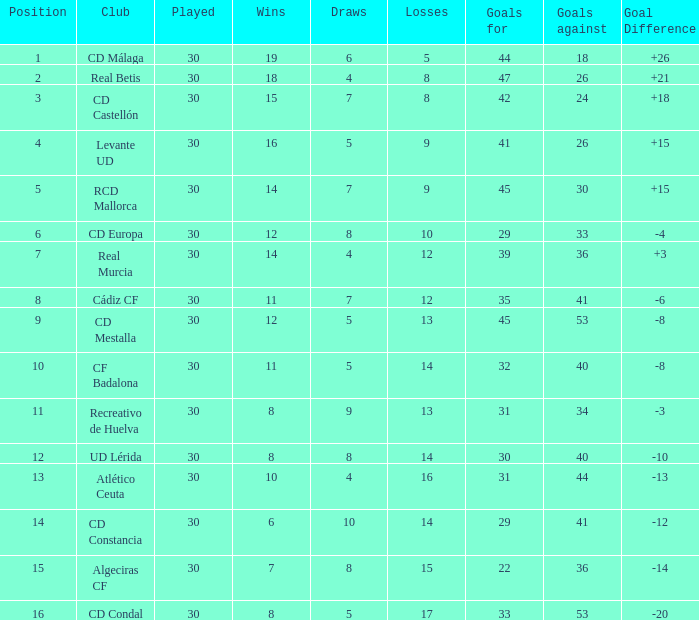Would you be able to parse every entry in this table? {'header': ['Position', 'Club', 'Played', 'Wins', 'Draws', 'Losses', 'Goals for', 'Goals against', 'Goal Difference'], 'rows': [['1', 'CD Málaga', '30', '19', '6', '5', '44', '18', '+26'], ['2', 'Real Betis', '30', '18', '4', '8', '47', '26', '+21'], ['3', 'CD Castellón', '30', '15', '7', '8', '42', '24', '+18'], ['4', 'Levante UD', '30', '16', '5', '9', '41', '26', '+15'], ['5', 'RCD Mallorca', '30', '14', '7', '9', '45', '30', '+15'], ['6', 'CD Europa', '30', '12', '8', '10', '29', '33', '-4'], ['7', 'Real Murcia', '30', '14', '4', '12', '39', '36', '+3'], ['8', 'Cádiz CF', '30', '11', '7', '12', '35', '41', '-6'], ['9', 'CD Mestalla', '30', '12', '5', '13', '45', '53', '-8'], ['10', 'CF Badalona', '30', '11', '5', '14', '32', '40', '-8'], ['11', 'Recreativo de Huelva', '30', '8', '9', '13', '31', '34', '-3'], ['12', 'UD Lérida', '30', '8', '8', '14', '30', '40', '-10'], ['13', 'Atlético Ceuta', '30', '10', '4', '16', '31', '44', '-13'], ['14', 'CD Constancia', '30', '6', '10', '14', '29', '41', '-12'], ['15', 'Algeciras CF', '30', '7', '8', '15', '22', '36', '-14'], ['16', 'CD Condal', '30', '8', '5', '17', '33', '53', '-20']]} What is the number of wins when the goals against is larger than 41, points is 29, and draws are larger than 5? 0.0. 